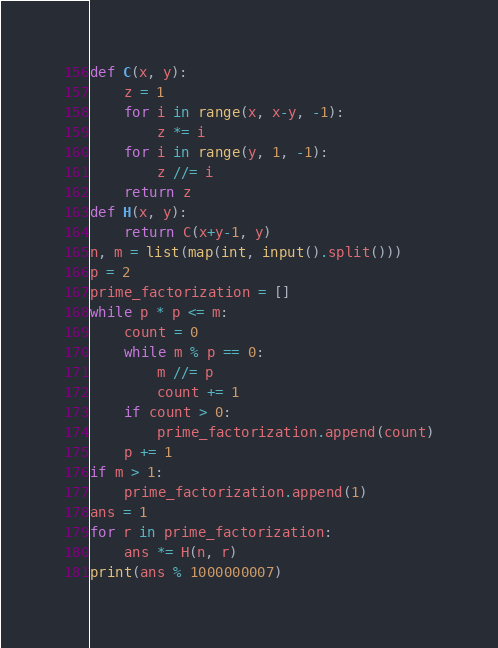Convert code to text. <code><loc_0><loc_0><loc_500><loc_500><_Python_>def C(x, y):
    z = 1
    for i in range(x, x-y, -1):
        z *= i
    for i in range(y, 1, -1):
        z //= i
    return z
def H(x, y):
    return C(x+y-1, y)
n, m = list(map(int, input().split()))
p = 2
prime_factorization = []
while p * p <= m:
    count = 0
    while m % p == 0:
        m //= p
        count += 1
    if count > 0:
        prime_factorization.append(count)
    p += 1
if m > 1:
    prime_factorization.append(1)
ans = 1
for r in prime_factorization:
    ans *= H(n, r)
print(ans % 1000000007)</code> 